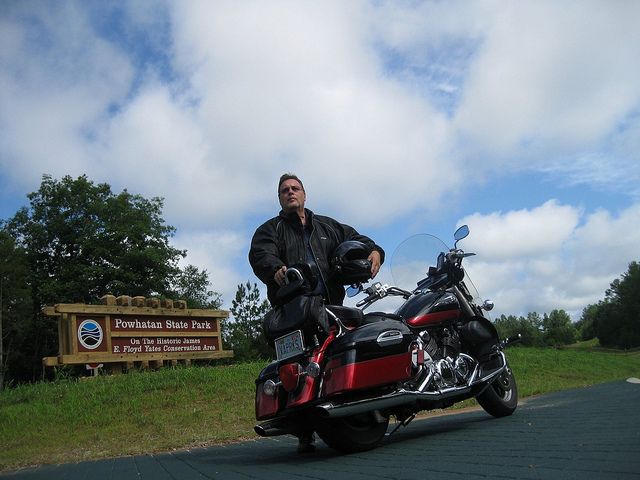<image>What are the last four numbers of the license plate number? It is unanswerable. The last four numbers of the license plate cannot be seen. What are the last four numbers of the license plate number? I don't know what are the last four numbers of the license plate number. It can be any of '2354', '1234', '4273', '2213' or '2545'. 